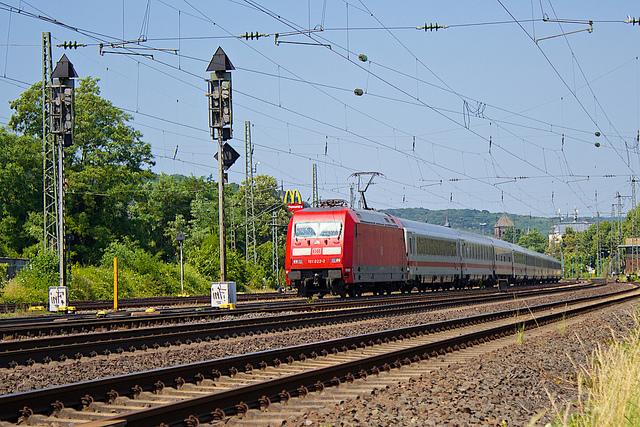Is the front car a different color than the rest?
Be succinct. Yes. Do you see any people walking down the road?
Give a very brief answer. No. What famous fast food restaurant do you see represented in this picture?
Be succinct. Mcdonald's. 